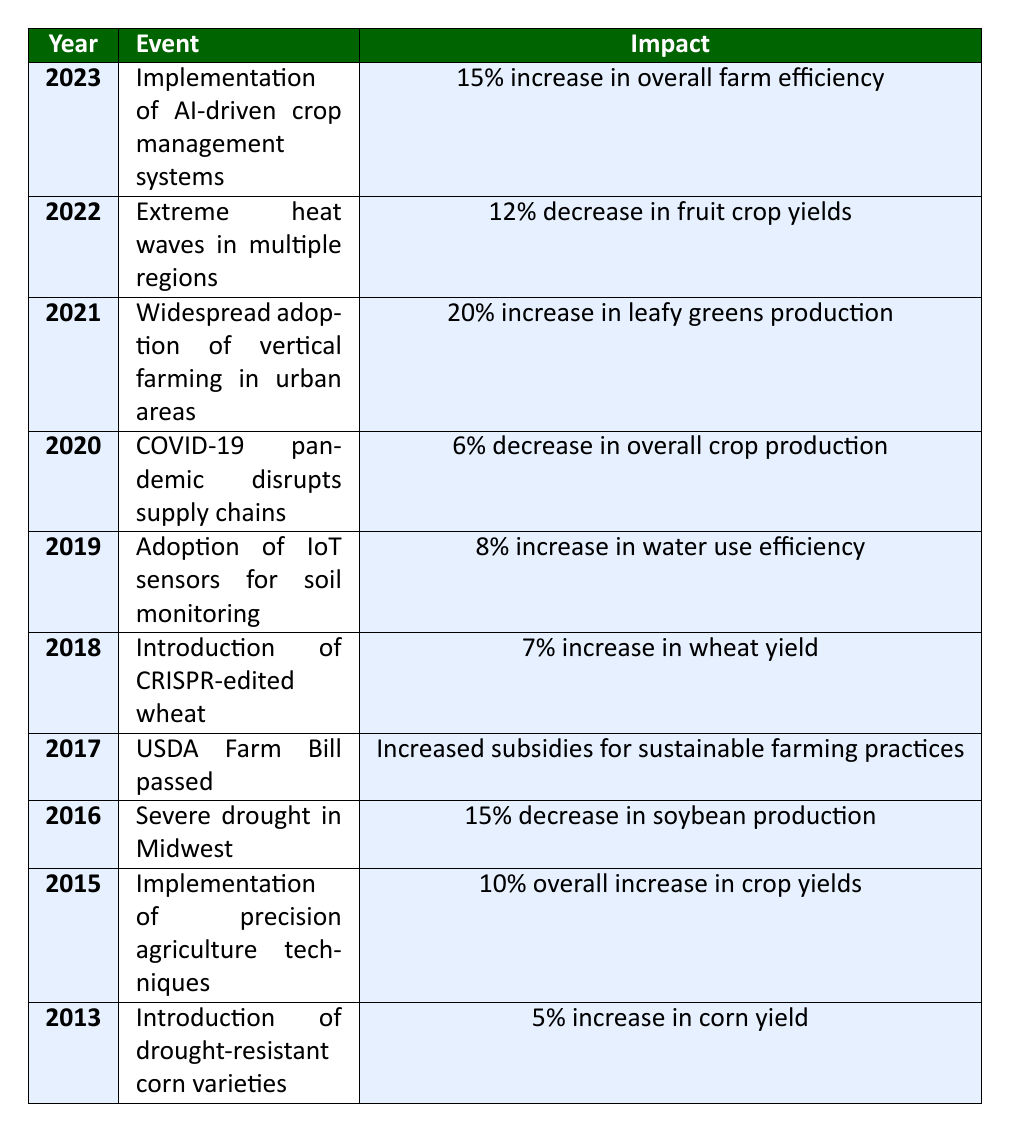What was the event in 2015 that led to an overall increase in crop yields? According to the table, in 2015, the event was the implementation of precision agriculture techniques, which resulted in a 10% overall increase in crop yields.
Answer: Implementation of precision agriculture techniques What percentage increase in corn yield was achieved with the introduction of drought-resistant corn varieties in 2013? The table states that in 2013, the introduction of drought-resistant corn varieties led to a 5% increase in corn yield.
Answer: 5% Was there a decrease in soybean production in 2016? Looking at the table, in 2016, there was a severe drought in the Midwest, which caused a 15% decrease in soybean production. Therefore, the answer is yes.
Answer: Yes What was the total percentage change in crop production from 2020 to 2021? The table shows a 6% decrease in overall crop production in 2020 and a 20% increase in leafy greens production in 2021. To find the total change, we consider only the decrease from 2020 as there is no direct crop production change number for 2021. Hence, the total percentage change is -6% for 2020 (assuming leafy greens production is part of the overall crop production).
Answer: -6% Which event in 2022 had a negative impact on crop yields, and what was the percentage decrease? In 2022, the event was extreme heat waves in multiple regions, resulting in a 12% decrease in fruit crop yields.
Answer: Extreme heat waves; 12% decrease 